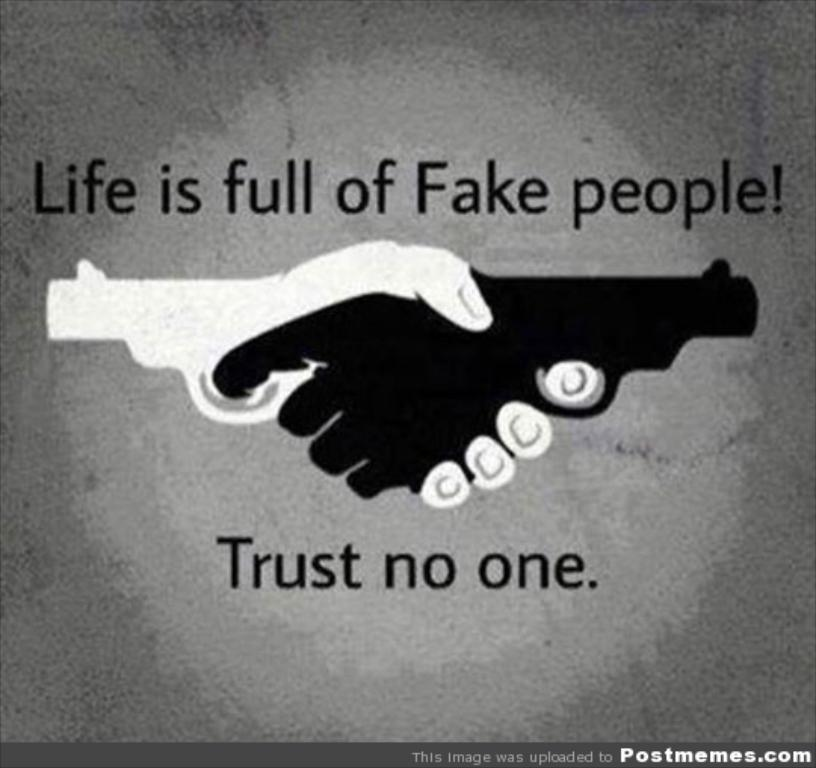<image>
Share a concise interpretation of the image provided. A meme stating that life is full of fake people! Trust no one. 